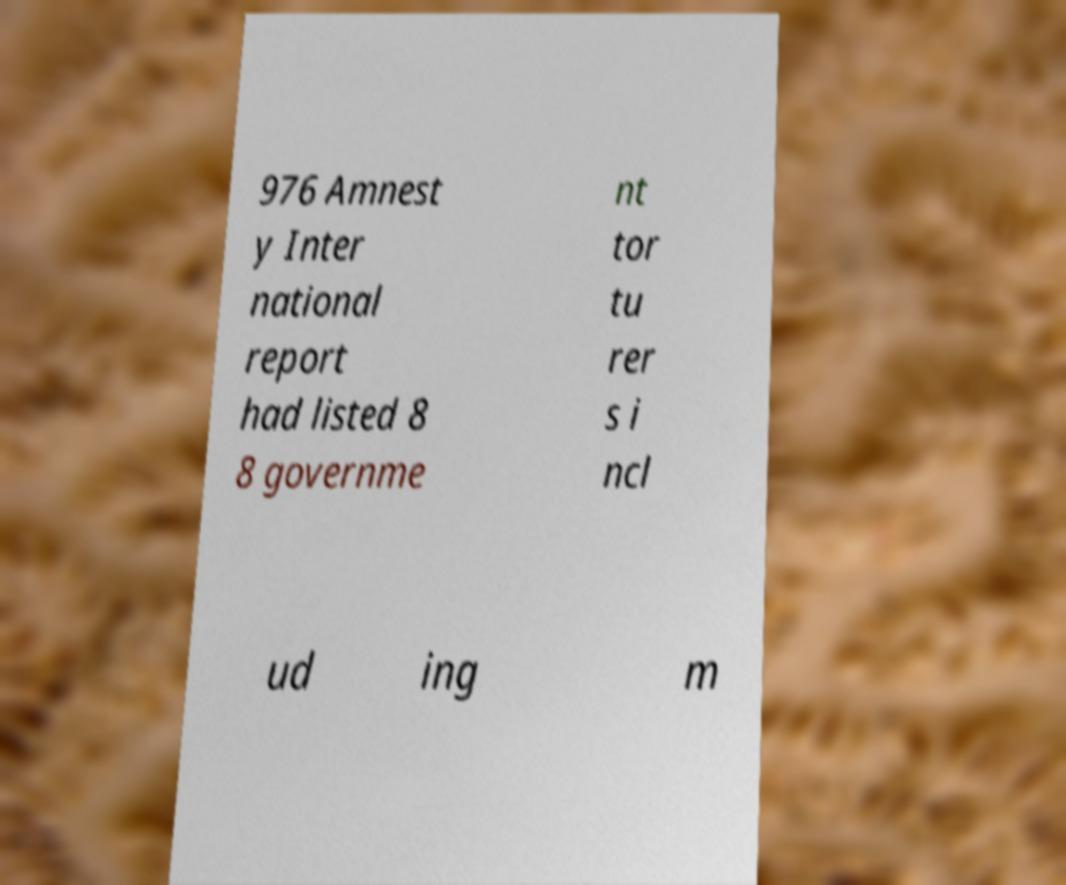Please read and relay the text visible in this image. What does it say? 976 Amnest y Inter national report had listed 8 8 governme nt tor tu rer s i ncl ud ing m 